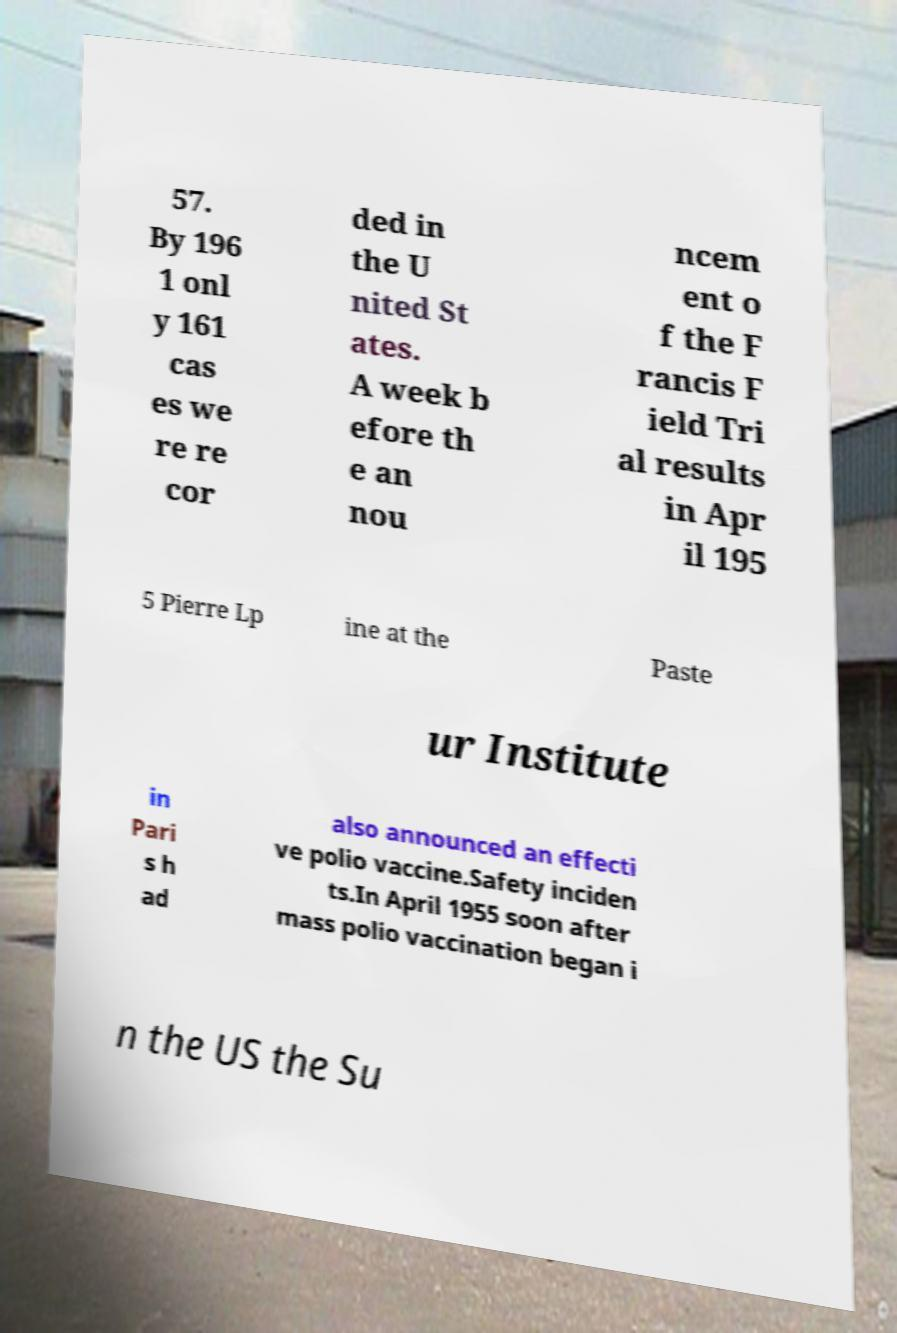Can you accurately transcribe the text from the provided image for me? 57. By 196 1 onl y 161 cas es we re re cor ded in the U nited St ates. A week b efore th e an nou ncem ent o f the F rancis F ield Tri al results in Apr il 195 5 Pierre Lp ine at the Paste ur Institute in Pari s h ad also announced an effecti ve polio vaccine.Safety inciden ts.In April 1955 soon after mass polio vaccination began i n the US the Su 